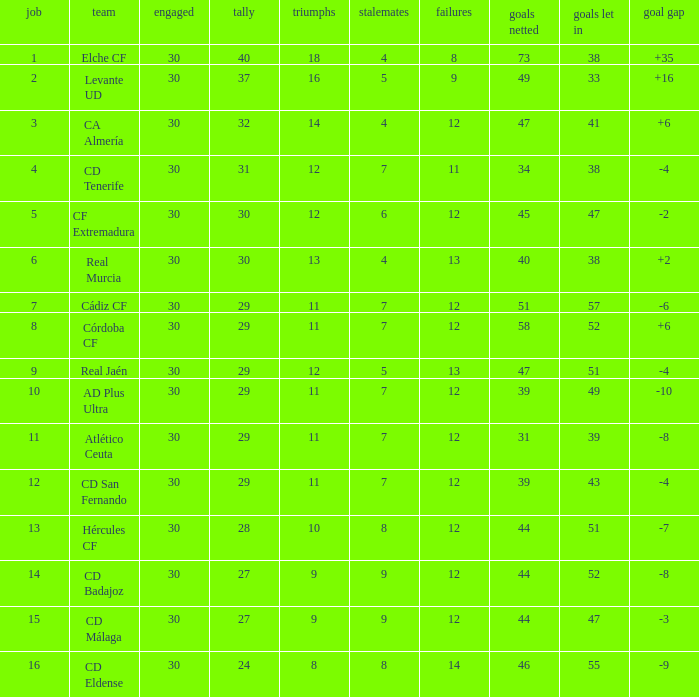What is the highest amount of goals with more than 51 goals against and less than 30 played? None. Parse the table in full. {'header': ['job', 'team', 'engaged', 'tally', 'triumphs', 'stalemates', 'failures', 'goals netted', 'goals let in', 'goal gap'], 'rows': [['1', 'Elche CF', '30', '40', '18', '4', '8', '73', '38', '+35'], ['2', 'Levante UD', '30', '37', '16', '5', '9', '49', '33', '+16'], ['3', 'CA Almería', '30', '32', '14', '4', '12', '47', '41', '+6'], ['4', 'CD Tenerife', '30', '31', '12', '7', '11', '34', '38', '-4'], ['5', 'CF Extremadura', '30', '30', '12', '6', '12', '45', '47', '-2'], ['6', 'Real Murcia', '30', '30', '13', '4', '13', '40', '38', '+2'], ['7', 'Cádiz CF', '30', '29', '11', '7', '12', '51', '57', '-6'], ['8', 'Córdoba CF', '30', '29', '11', '7', '12', '58', '52', '+6'], ['9', 'Real Jaén', '30', '29', '12', '5', '13', '47', '51', '-4'], ['10', 'AD Plus Ultra', '30', '29', '11', '7', '12', '39', '49', '-10'], ['11', 'Atlético Ceuta', '30', '29', '11', '7', '12', '31', '39', '-8'], ['12', 'CD San Fernando', '30', '29', '11', '7', '12', '39', '43', '-4'], ['13', 'Hércules CF', '30', '28', '10', '8', '12', '44', '51', '-7'], ['14', 'CD Badajoz', '30', '27', '9', '9', '12', '44', '52', '-8'], ['15', 'CD Málaga', '30', '27', '9', '9', '12', '44', '47', '-3'], ['16', 'CD Eldense', '30', '24', '8', '8', '14', '46', '55', '-9']]} 